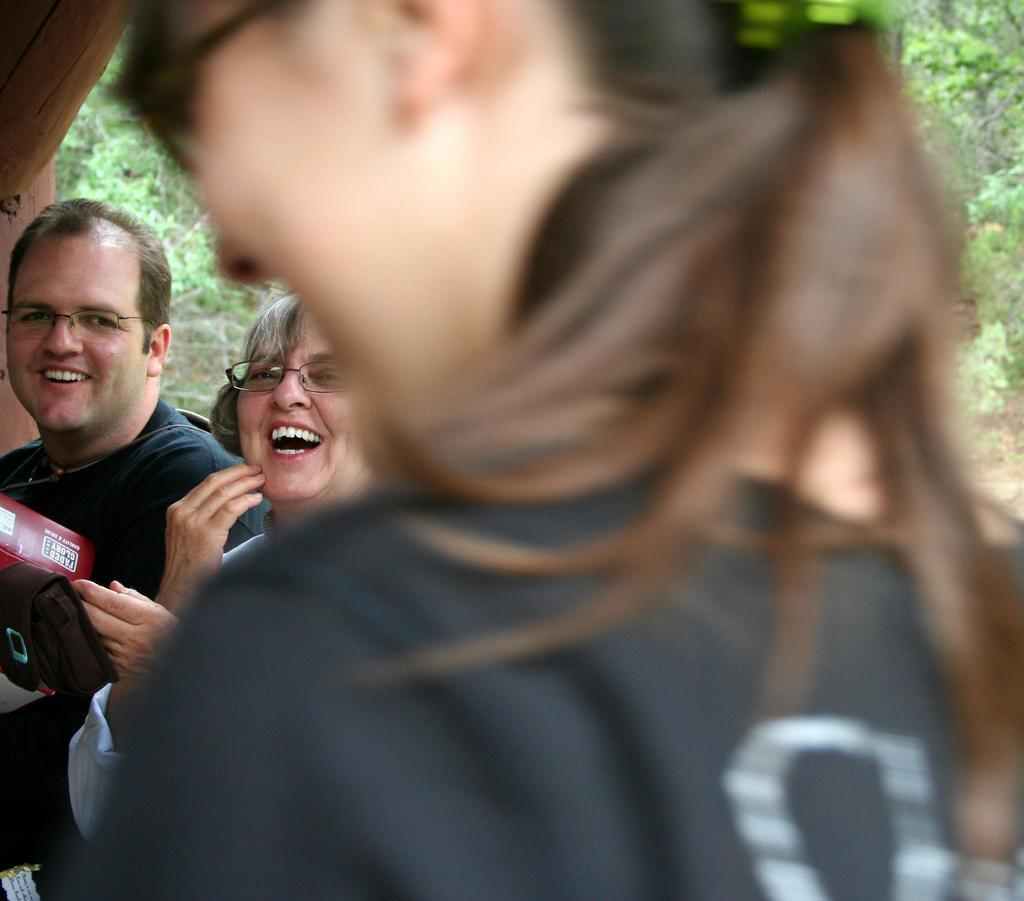How many people are present in the image? There are three people in the image. What expressions do the people have in the image? All three people are smiling in the image. What type of nerve can be seen in the image? There is no nerve present in the image. What color is the chalk used by the people in the image? There is no chalk or indication of chalk use in the image. 